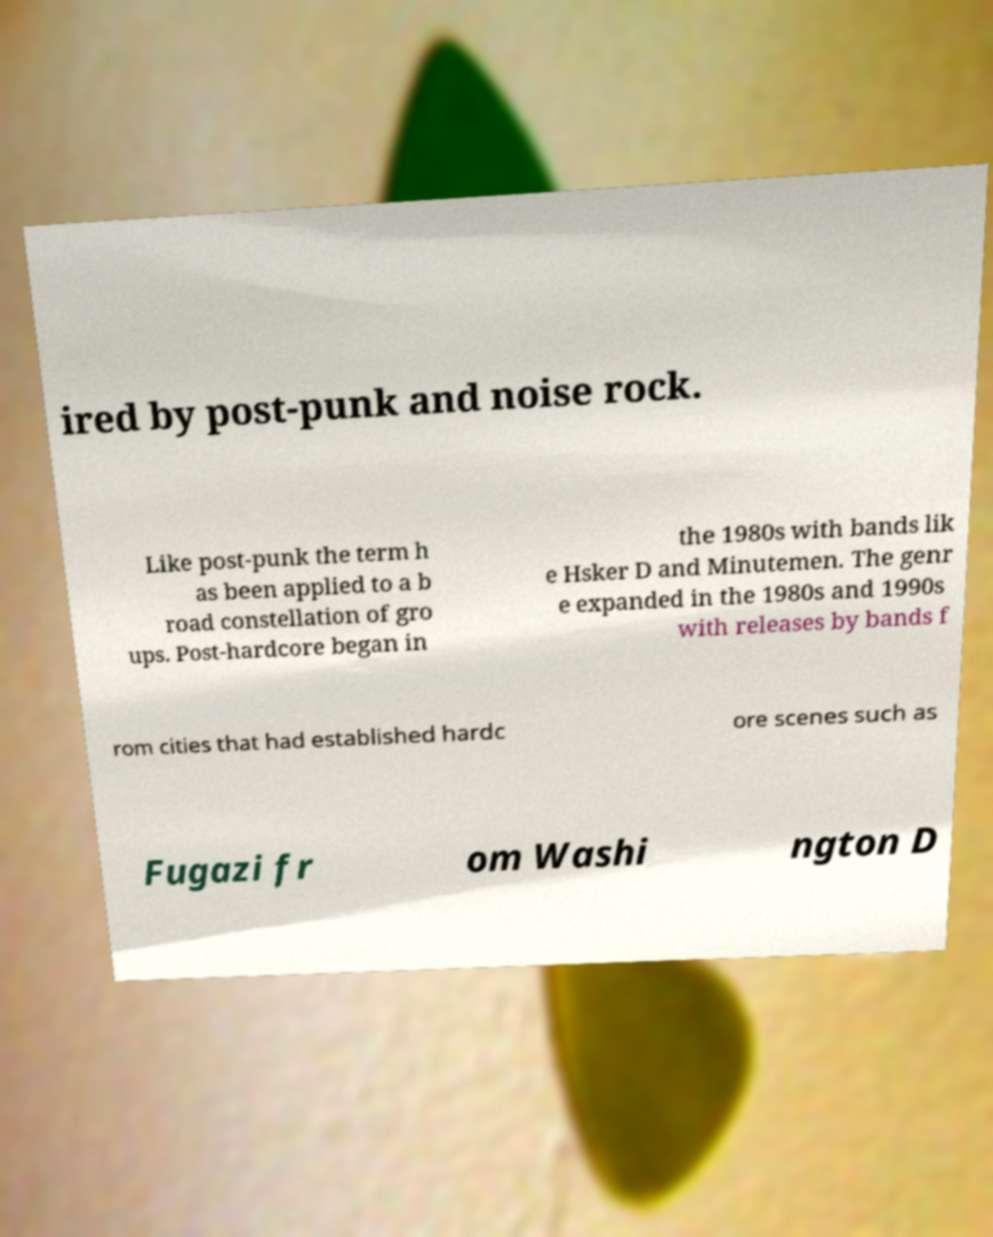Could you extract and type out the text from this image? ired by post-punk and noise rock. Like post-punk the term h as been applied to a b road constellation of gro ups. Post-hardcore began in the 1980s with bands lik e Hsker D and Minutemen. The genr e expanded in the 1980s and 1990s with releases by bands f rom cities that had established hardc ore scenes such as Fugazi fr om Washi ngton D 